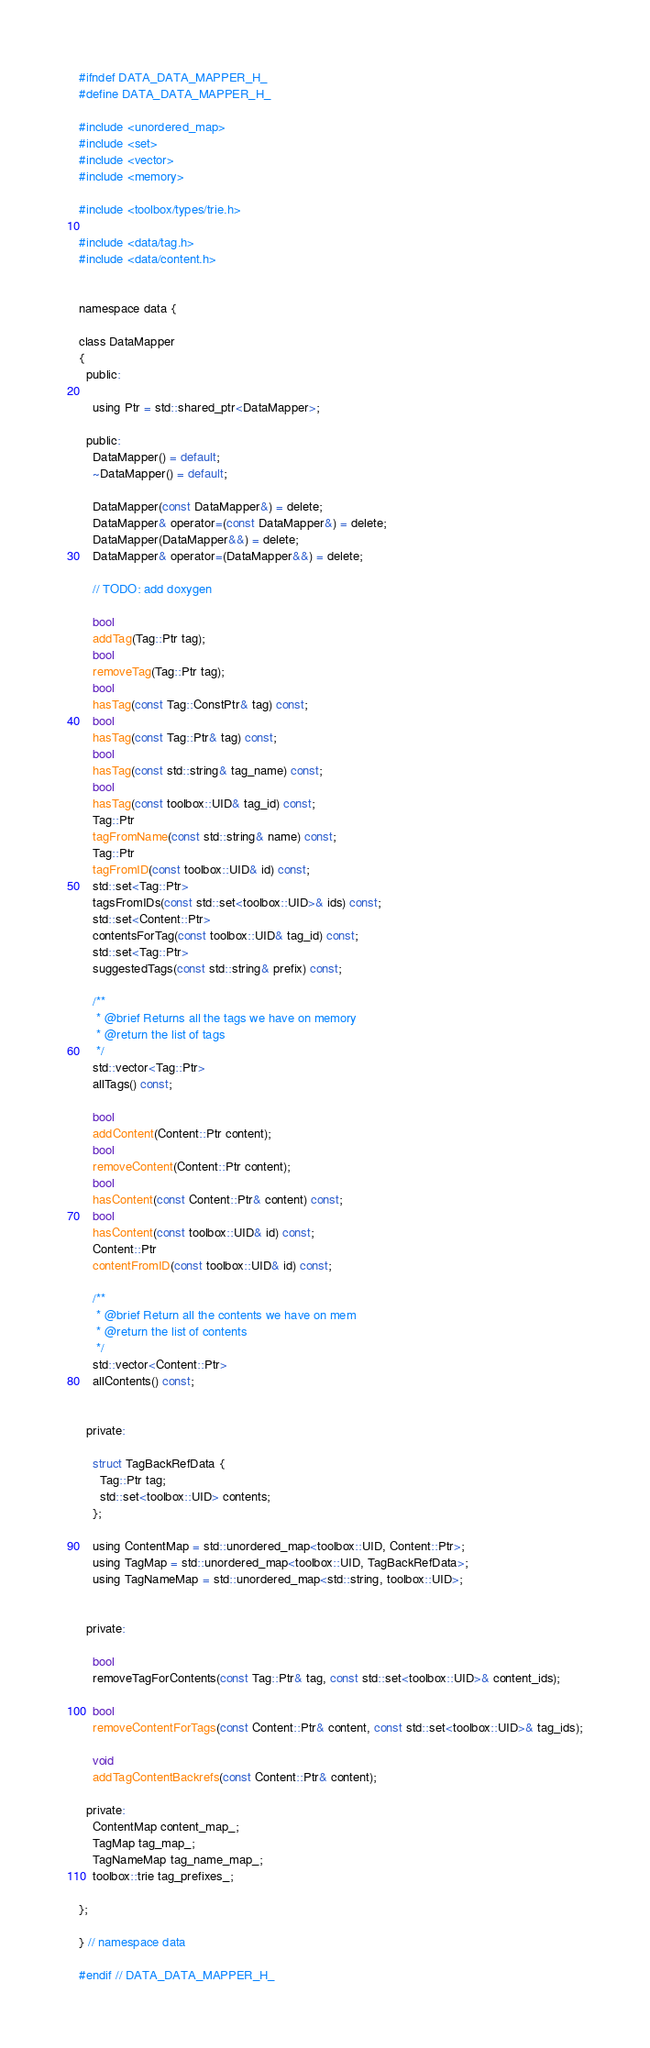<code> <loc_0><loc_0><loc_500><loc_500><_C_>#ifndef DATA_DATA_MAPPER_H_
#define DATA_DATA_MAPPER_H_

#include <unordered_map>
#include <set>
#include <vector>
#include <memory>

#include <toolbox/types/trie.h>

#include <data/tag.h>
#include <data/content.h>


namespace data {

class DataMapper
{
  public:

    using Ptr = std::shared_ptr<DataMapper>;

  public:
    DataMapper() = default;
    ~DataMapper() = default;

    DataMapper(const DataMapper&) = delete;
    DataMapper& operator=(const DataMapper&) = delete;
    DataMapper(DataMapper&&) = delete;
    DataMapper& operator=(DataMapper&&) = delete;

    // TODO: add doxygen

    bool
    addTag(Tag::Ptr tag);
    bool
    removeTag(Tag::Ptr tag);
    bool
    hasTag(const Tag::ConstPtr& tag) const;
    bool
    hasTag(const Tag::Ptr& tag) const;
    bool
    hasTag(const std::string& tag_name) const;
    bool
    hasTag(const toolbox::UID& tag_id) const;
    Tag::Ptr
    tagFromName(const std::string& name) const;
    Tag::Ptr
    tagFromID(const toolbox::UID& id) const;
    std::set<Tag::Ptr>
    tagsFromIDs(const std::set<toolbox::UID>& ids) const;
    std::set<Content::Ptr>
    contentsForTag(const toolbox::UID& tag_id) const;
    std::set<Tag::Ptr>
    suggestedTags(const std::string& prefix) const;

    /**
     * @brief Returns all the tags we have on memory
     * @return the list of tags
     */
    std::vector<Tag::Ptr>
    allTags() const;

    bool
    addContent(Content::Ptr content);
    bool
    removeContent(Content::Ptr content);
    bool
    hasContent(const Content::Ptr& content) const;
    bool
    hasContent(const toolbox::UID& id) const;
    Content::Ptr
    contentFromID(const toolbox::UID& id) const;

    /**
     * @brief Return all the contents we have on mem
     * @return the list of contents
     */
    std::vector<Content::Ptr>
    allContents() const;


  private:

    struct TagBackRefData {
      Tag::Ptr tag;
      std::set<toolbox::UID> contents;
    };

    using ContentMap = std::unordered_map<toolbox::UID, Content::Ptr>;
    using TagMap = std::unordered_map<toolbox::UID, TagBackRefData>;
    using TagNameMap = std::unordered_map<std::string, toolbox::UID>;


  private:

    bool
    removeTagForContents(const Tag::Ptr& tag, const std::set<toolbox::UID>& content_ids);

    bool
    removeContentForTags(const Content::Ptr& content, const std::set<toolbox::UID>& tag_ids);

    void
    addTagContentBackrefs(const Content::Ptr& content);

  private:
    ContentMap content_map_;
    TagMap tag_map_;
    TagNameMap tag_name_map_;
    toolbox::trie tag_prefixes_;

};

} // namespace data

#endif // DATA_DATA_MAPPER_H_
</code> 